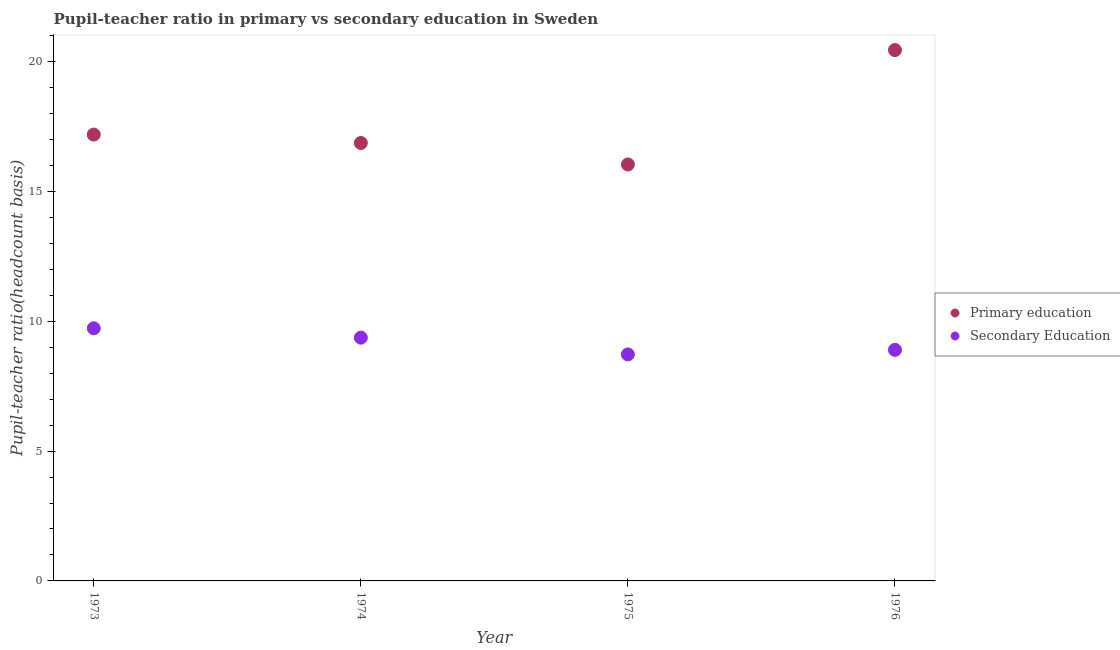How many different coloured dotlines are there?
Provide a short and direct response. 2. What is the pupil teacher ratio on secondary education in 1974?
Ensure brevity in your answer.  9.37. Across all years, what is the maximum pupil-teacher ratio in primary education?
Provide a short and direct response. 20.44. Across all years, what is the minimum pupil-teacher ratio in primary education?
Give a very brief answer. 16.03. In which year was the pupil-teacher ratio in primary education maximum?
Provide a succinct answer. 1976. In which year was the pupil-teacher ratio in primary education minimum?
Your response must be concise. 1975. What is the total pupil-teacher ratio in primary education in the graph?
Offer a very short reply. 70.52. What is the difference between the pupil teacher ratio on secondary education in 1974 and that in 1975?
Your answer should be compact. 0.65. What is the difference between the pupil teacher ratio on secondary education in 1975 and the pupil-teacher ratio in primary education in 1976?
Provide a succinct answer. -11.72. What is the average pupil-teacher ratio in primary education per year?
Keep it short and to the point. 17.63. In the year 1973, what is the difference between the pupil-teacher ratio in primary education and pupil teacher ratio on secondary education?
Your response must be concise. 7.46. What is the ratio of the pupil teacher ratio on secondary education in 1974 to that in 1976?
Provide a short and direct response. 1.05. Is the pupil teacher ratio on secondary education in 1974 less than that in 1975?
Provide a short and direct response. No. What is the difference between the highest and the second highest pupil-teacher ratio in primary education?
Offer a terse response. 3.25. What is the difference between the highest and the lowest pupil-teacher ratio in primary education?
Ensure brevity in your answer.  4.4. Is the sum of the pupil-teacher ratio in primary education in 1973 and 1974 greater than the maximum pupil teacher ratio on secondary education across all years?
Give a very brief answer. Yes. Does the pupil-teacher ratio in primary education monotonically increase over the years?
Offer a very short reply. No. Is the pupil teacher ratio on secondary education strictly less than the pupil-teacher ratio in primary education over the years?
Offer a terse response. Yes. How many years are there in the graph?
Your answer should be very brief. 4. Does the graph contain grids?
Make the answer very short. No. How many legend labels are there?
Keep it short and to the point. 2. How are the legend labels stacked?
Give a very brief answer. Vertical. What is the title of the graph?
Keep it short and to the point. Pupil-teacher ratio in primary vs secondary education in Sweden. Does "Birth rate" appear as one of the legend labels in the graph?
Your answer should be very brief. No. What is the label or title of the Y-axis?
Your answer should be compact. Pupil-teacher ratio(headcount basis). What is the Pupil-teacher ratio(headcount basis) of Primary education in 1973?
Make the answer very short. 17.19. What is the Pupil-teacher ratio(headcount basis) in Secondary Education in 1973?
Your answer should be compact. 9.73. What is the Pupil-teacher ratio(headcount basis) in Primary education in 1974?
Ensure brevity in your answer.  16.86. What is the Pupil-teacher ratio(headcount basis) in Secondary Education in 1974?
Offer a terse response. 9.37. What is the Pupil-teacher ratio(headcount basis) in Primary education in 1975?
Your response must be concise. 16.03. What is the Pupil-teacher ratio(headcount basis) in Secondary Education in 1975?
Give a very brief answer. 8.72. What is the Pupil-teacher ratio(headcount basis) in Primary education in 1976?
Provide a short and direct response. 20.44. What is the Pupil-teacher ratio(headcount basis) of Secondary Education in 1976?
Offer a very short reply. 8.9. Across all years, what is the maximum Pupil-teacher ratio(headcount basis) of Primary education?
Your response must be concise. 20.44. Across all years, what is the maximum Pupil-teacher ratio(headcount basis) in Secondary Education?
Keep it short and to the point. 9.73. Across all years, what is the minimum Pupil-teacher ratio(headcount basis) of Primary education?
Provide a short and direct response. 16.03. Across all years, what is the minimum Pupil-teacher ratio(headcount basis) of Secondary Education?
Keep it short and to the point. 8.72. What is the total Pupil-teacher ratio(headcount basis) of Primary education in the graph?
Provide a succinct answer. 70.52. What is the total Pupil-teacher ratio(headcount basis) in Secondary Education in the graph?
Your response must be concise. 36.71. What is the difference between the Pupil-teacher ratio(headcount basis) of Primary education in 1973 and that in 1974?
Offer a terse response. 0.32. What is the difference between the Pupil-teacher ratio(headcount basis) of Secondary Education in 1973 and that in 1974?
Keep it short and to the point. 0.36. What is the difference between the Pupil-teacher ratio(headcount basis) in Primary education in 1973 and that in 1975?
Give a very brief answer. 1.15. What is the difference between the Pupil-teacher ratio(headcount basis) in Secondary Education in 1973 and that in 1975?
Give a very brief answer. 1.01. What is the difference between the Pupil-teacher ratio(headcount basis) in Primary education in 1973 and that in 1976?
Provide a succinct answer. -3.25. What is the difference between the Pupil-teacher ratio(headcount basis) in Secondary Education in 1973 and that in 1976?
Your answer should be very brief. 0.83. What is the difference between the Pupil-teacher ratio(headcount basis) in Primary education in 1974 and that in 1975?
Provide a short and direct response. 0.83. What is the difference between the Pupil-teacher ratio(headcount basis) in Secondary Education in 1974 and that in 1975?
Make the answer very short. 0.65. What is the difference between the Pupil-teacher ratio(headcount basis) of Primary education in 1974 and that in 1976?
Make the answer very short. -3.58. What is the difference between the Pupil-teacher ratio(headcount basis) in Secondary Education in 1974 and that in 1976?
Your response must be concise. 0.47. What is the difference between the Pupil-teacher ratio(headcount basis) in Primary education in 1975 and that in 1976?
Give a very brief answer. -4.4. What is the difference between the Pupil-teacher ratio(headcount basis) in Secondary Education in 1975 and that in 1976?
Give a very brief answer. -0.18. What is the difference between the Pupil-teacher ratio(headcount basis) of Primary education in 1973 and the Pupil-teacher ratio(headcount basis) of Secondary Education in 1974?
Provide a succinct answer. 7.82. What is the difference between the Pupil-teacher ratio(headcount basis) in Primary education in 1973 and the Pupil-teacher ratio(headcount basis) in Secondary Education in 1975?
Make the answer very short. 8.46. What is the difference between the Pupil-teacher ratio(headcount basis) in Primary education in 1973 and the Pupil-teacher ratio(headcount basis) in Secondary Education in 1976?
Provide a short and direct response. 8.29. What is the difference between the Pupil-teacher ratio(headcount basis) of Primary education in 1974 and the Pupil-teacher ratio(headcount basis) of Secondary Education in 1975?
Your answer should be very brief. 8.14. What is the difference between the Pupil-teacher ratio(headcount basis) in Primary education in 1974 and the Pupil-teacher ratio(headcount basis) in Secondary Education in 1976?
Your response must be concise. 7.97. What is the difference between the Pupil-teacher ratio(headcount basis) of Primary education in 1975 and the Pupil-teacher ratio(headcount basis) of Secondary Education in 1976?
Offer a very short reply. 7.14. What is the average Pupil-teacher ratio(headcount basis) of Primary education per year?
Your answer should be compact. 17.63. What is the average Pupil-teacher ratio(headcount basis) in Secondary Education per year?
Your answer should be compact. 9.18. In the year 1973, what is the difference between the Pupil-teacher ratio(headcount basis) of Primary education and Pupil-teacher ratio(headcount basis) of Secondary Education?
Your answer should be compact. 7.46. In the year 1974, what is the difference between the Pupil-teacher ratio(headcount basis) in Primary education and Pupil-teacher ratio(headcount basis) in Secondary Education?
Provide a succinct answer. 7.5. In the year 1975, what is the difference between the Pupil-teacher ratio(headcount basis) in Primary education and Pupil-teacher ratio(headcount basis) in Secondary Education?
Your answer should be very brief. 7.31. In the year 1976, what is the difference between the Pupil-teacher ratio(headcount basis) of Primary education and Pupil-teacher ratio(headcount basis) of Secondary Education?
Your answer should be compact. 11.54. What is the ratio of the Pupil-teacher ratio(headcount basis) in Primary education in 1973 to that in 1974?
Give a very brief answer. 1.02. What is the ratio of the Pupil-teacher ratio(headcount basis) of Secondary Education in 1973 to that in 1974?
Keep it short and to the point. 1.04. What is the ratio of the Pupil-teacher ratio(headcount basis) of Primary education in 1973 to that in 1975?
Your answer should be very brief. 1.07. What is the ratio of the Pupil-teacher ratio(headcount basis) in Secondary Education in 1973 to that in 1975?
Provide a succinct answer. 1.12. What is the ratio of the Pupil-teacher ratio(headcount basis) in Primary education in 1973 to that in 1976?
Keep it short and to the point. 0.84. What is the ratio of the Pupil-teacher ratio(headcount basis) of Secondary Education in 1973 to that in 1976?
Keep it short and to the point. 1.09. What is the ratio of the Pupil-teacher ratio(headcount basis) in Primary education in 1974 to that in 1975?
Provide a short and direct response. 1.05. What is the ratio of the Pupil-teacher ratio(headcount basis) in Secondary Education in 1974 to that in 1975?
Offer a very short reply. 1.07. What is the ratio of the Pupil-teacher ratio(headcount basis) of Primary education in 1974 to that in 1976?
Your answer should be compact. 0.82. What is the ratio of the Pupil-teacher ratio(headcount basis) of Secondary Education in 1974 to that in 1976?
Your response must be concise. 1.05. What is the ratio of the Pupil-teacher ratio(headcount basis) of Primary education in 1975 to that in 1976?
Offer a terse response. 0.78. What is the ratio of the Pupil-teacher ratio(headcount basis) of Secondary Education in 1975 to that in 1976?
Make the answer very short. 0.98. What is the difference between the highest and the second highest Pupil-teacher ratio(headcount basis) in Primary education?
Make the answer very short. 3.25. What is the difference between the highest and the second highest Pupil-teacher ratio(headcount basis) of Secondary Education?
Offer a very short reply. 0.36. What is the difference between the highest and the lowest Pupil-teacher ratio(headcount basis) in Primary education?
Make the answer very short. 4.4. 